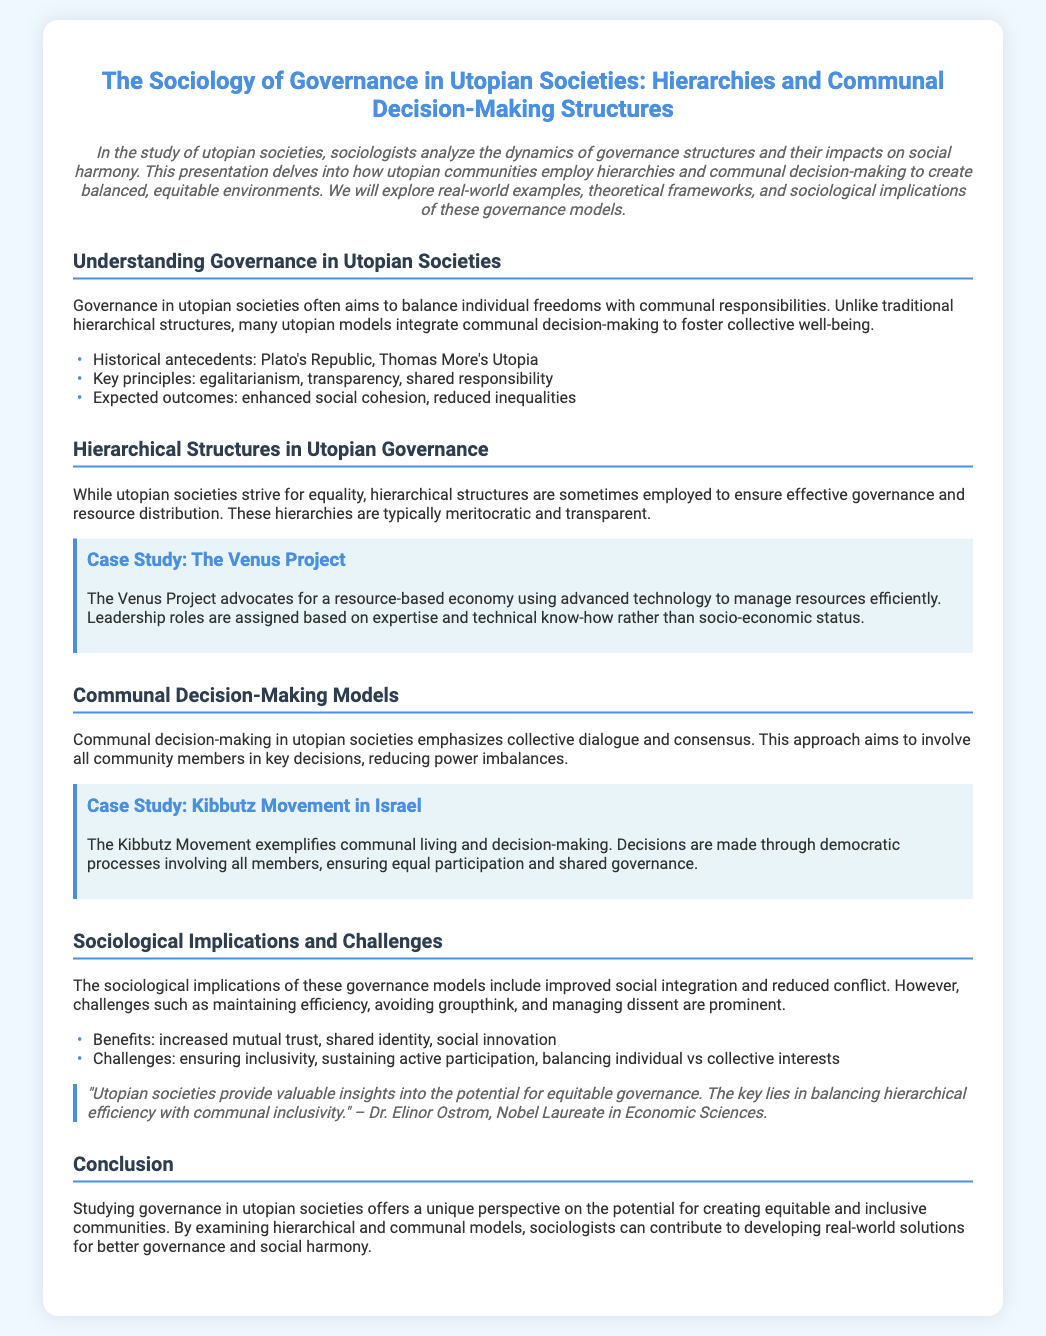What are the key principles of governance in utopian societies? The key principles are mentioned in the document under "Understanding Governance in Utopian Societies," specifically listing egalitarianism, transparency, and shared responsibility.
Answer: egalitarianism, transparency, shared responsibility What does the Venus Project advocate for? The Venus Project is highlighted in the section on hierarchical structures, where it advocates for a resource-based economy using advanced technology.
Answer: resource-based economy What is the case study that exemplifies communal living and decision-making? In the section on communal decision-making models, the Kibbutz Movement in Israel is provided as a case study exemplifying this approach.
Answer: Kibbutz Movement in Israel What are the benefits of communal decision-making as per the document? The benefits are outlined in the section on sociological implications and challenges, noting increased mutual trust, shared identity, and social innovation.
Answer: increased mutual trust, shared identity, social innovation Who is quoted regarding equitable governance in the document? The quote in the sociological implications section is attributed to Dr. Elinor Ostrom, a Nobel Laureate in Economic Sciences.
Answer: Dr. Elinor Ostrom 